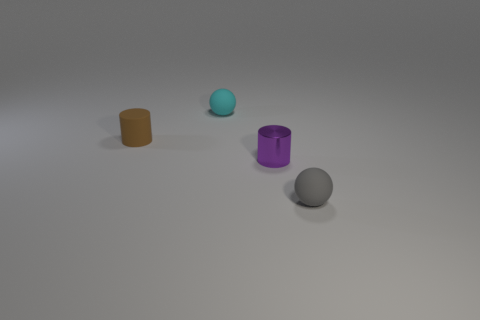Add 4 small gray matte things. How many objects exist? 8 Subtract all brown cylinders. Subtract all red balls. How many cylinders are left? 1 Subtract all green blocks. How many brown cylinders are left? 1 Subtract all red rubber blocks. Subtract all rubber balls. How many objects are left? 2 Add 2 gray rubber things. How many gray rubber things are left? 3 Add 3 gray matte balls. How many gray matte balls exist? 4 Subtract 0 cyan cylinders. How many objects are left? 4 Subtract 1 cylinders. How many cylinders are left? 1 